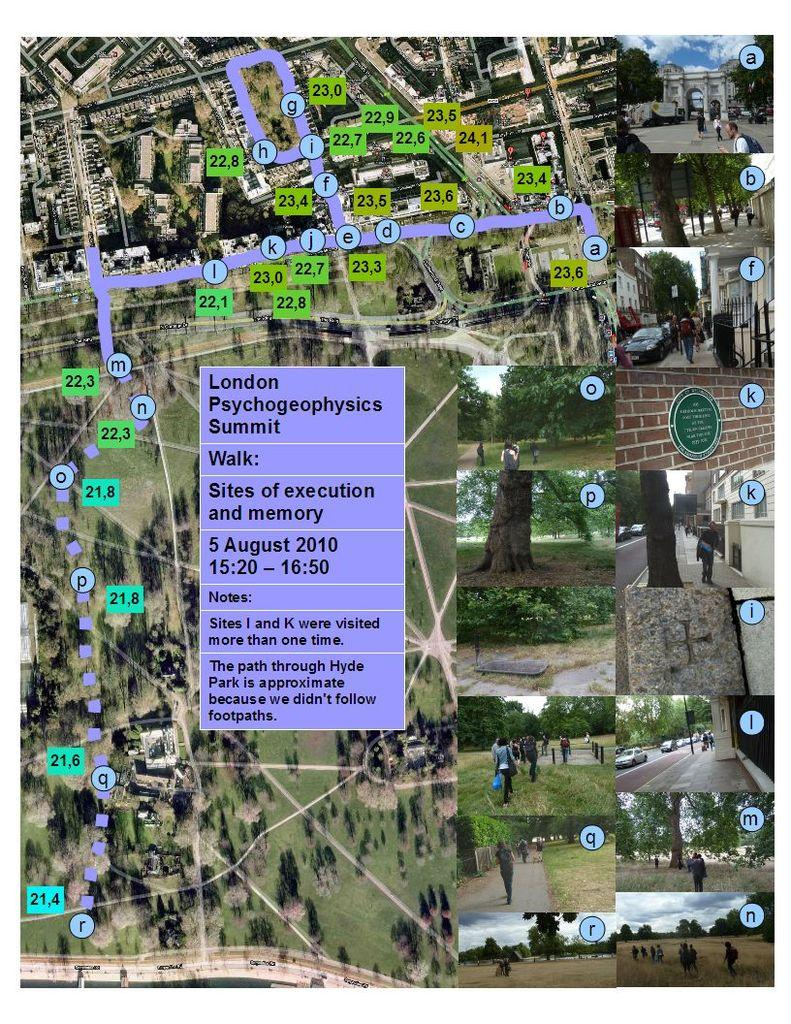What is the main subject of the image? The main subject of the image is a route map. What can be observed on the route map? The route map has markings on it and text. What is present on the right side of the image? There are collage images on the right side of the image. What types of objects or elements are included in the collage images? The collage images include people, trees, cars, buildings, name boards, and pavements. How does the route map produce steam in the image? The route map does not produce steam in the image; it is a static map with markings and text. 